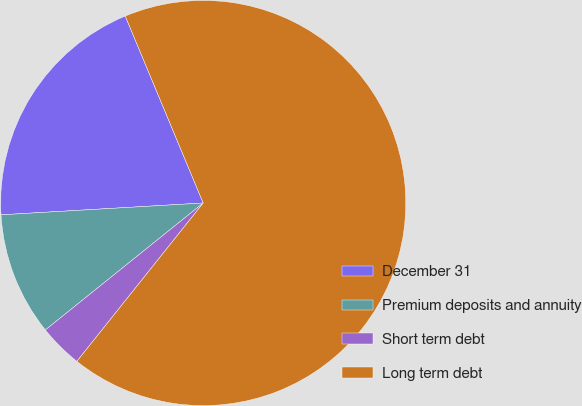Convert chart to OTSL. <chart><loc_0><loc_0><loc_500><loc_500><pie_chart><fcel>December 31<fcel>Premium deposits and annuity<fcel>Short term debt<fcel>Long term debt<nl><fcel>19.64%<fcel>9.85%<fcel>3.5%<fcel>67.0%<nl></chart> 